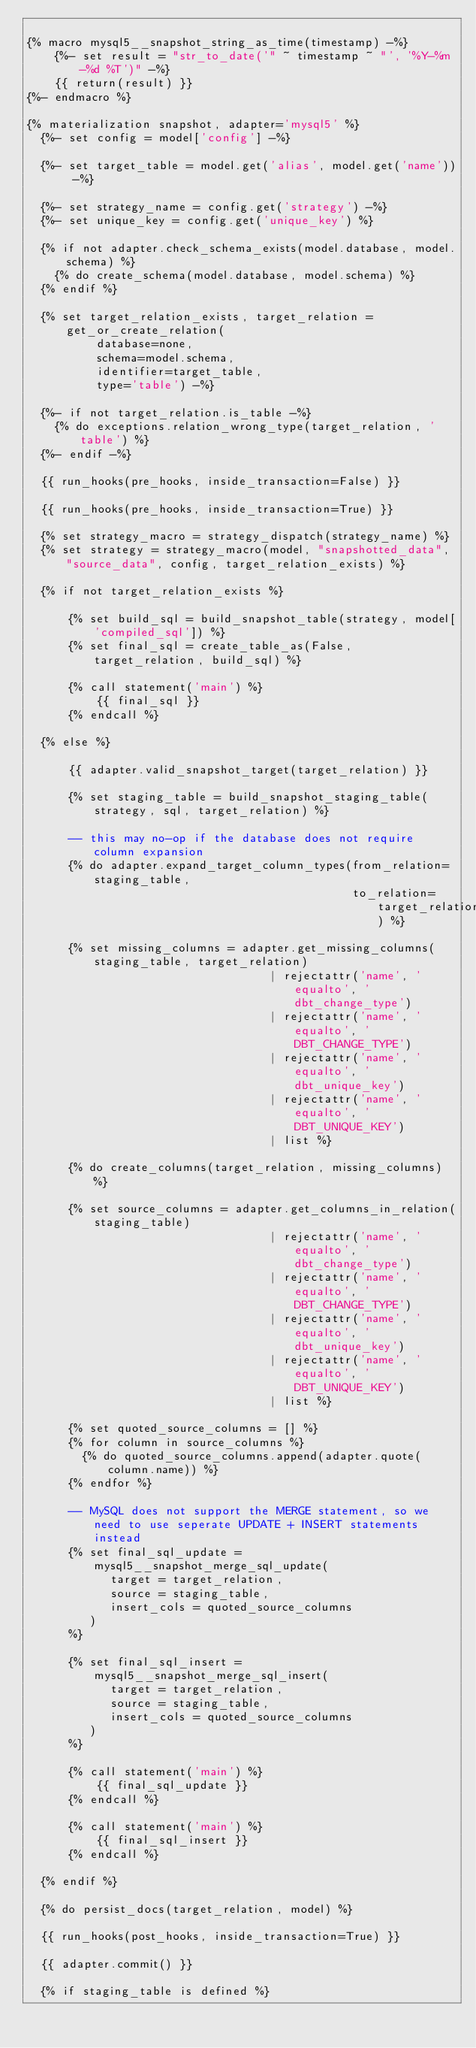<code> <loc_0><loc_0><loc_500><loc_500><_SQL_>
{% macro mysql5__snapshot_string_as_time(timestamp) -%}
    {%- set result = "str_to_date('" ~ timestamp ~ "', '%Y-%m-%d %T')" -%}
    {{ return(result) }}
{%- endmacro %}

{% materialization snapshot, adapter='mysql5' %}
  {%- set config = model['config'] -%}

  {%- set target_table = model.get('alias', model.get('name')) -%}

  {%- set strategy_name = config.get('strategy') -%}
  {%- set unique_key = config.get('unique_key') %}

  {% if not adapter.check_schema_exists(model.database, model.schema) %}
    {% do create_schema(model.database, model.schema) %}
  {% endif %}

  {% set target_relation_exists, target_relation = get_or_create_relation(
          database=none,
          schema=model.schema,
          identifier=target_table,
          type='table') -%}

  {%- if not target_relation.is_table -%}
    {% do exceptions.relation_wrong_type(target_relation, 'table') %}
  {%- endif -%}

  {{ run_hooks(pre_hooks, inside_transaction=False) }}

  {{ run_hooks(pre_hooks, inside_transaction=True) }}

  {% set strategy_macro = strategy_dispatch(strategy_name) %}
  {% set strategy = strategy_macro(model, "snapshotted_data", "source_data", config, target_relation_exists) %}

  {% if not target_relation_exists %}

      {% set build_sql = build_snapshot_table(strategy, model['compiled_sql']) %}
      {% set final_sql = create_table_as(False, target_relation, build_sql) %}

      {% call statement('main') %}
          {{ final_sql }}
      {% endcall %}

  {% else %}

      {{ adapter.valid_snapshot_target(target_relation) }}

      {% set staging_table = build_snapshot_staging_table(strategy, sql, target_relation) %}

      -- this may no-op if the database does not require column expansion
      {% do adapter.expand_target_column_types(from_relation=staging_table,
                                               to_relation=target_relation) %}

      {% set missing_columns = adapter.get_missing_columns(staging_table, target_relation)
                                   | rejectattr('name', 'equalto', 'dbt_change_type')
                                   | rejectattr('name', 'equalto', 'DBT_CHANGE_TYPE')
                                   | rejectattr('name', 'equalto', 'dbt_unique_key')
                                   | rejectattr('name', 'equalto', 'DBT_UNIQUE_KEY')
                                   | list %}

      {% do create_columns(target_relation, missing_columns) %}

      {% set source_columns = adapter.get_columns_in_relation(staging_table)
                                   | rejectattr('name', 'equalto', 'dbt_change_type')
                                   | rejectattr('name', 'equalto', 'DBT_CHANGE_TYPE')
                                   | rejectattr('name', 'equalto', 'dbt_unique_key')
                                   | rejectattr('name', 'equalto', 'DBT_UNIQUE_KEY')
                                   | list %}

      {% set quoted_source_columns = [] %}
      {% for column in source_columns %}
        {% do quoted_source_columns.append(adapter.quote(column.name)) %}
      {% endfor %}

      -- MySQL does not support the MERGE statement, so we need to use seperate UPDATE + INSERT statements instead
      {% set final_sql_update = mysql5__snapshot_merge_sql_update(
            target = target_relation,
            source = staging_table,
            insert_cols = quoted_source_columns
         )
      %}

      {% set final_sql_insert = mysql5__snapshot_merge_sql_insert(
            target = target_relation,
            source = staging_table,
            insert_cols = quoted_source_columns
         )
      %}

      {% call statement('main') %}
          {{ final_sql_update }}
      {% endcall %}

      {% call statement('main') %}
          {{ final_sql_insert }}
      {% endcall %}

  {% endif %}

  {% do persist_docs(target_relation, model) %}

  {{ run_hooks(post_hooks, inside_transaction=True) }}

  {{ adapter.commit() }}

  {% if staging_table is defined %}</code> 